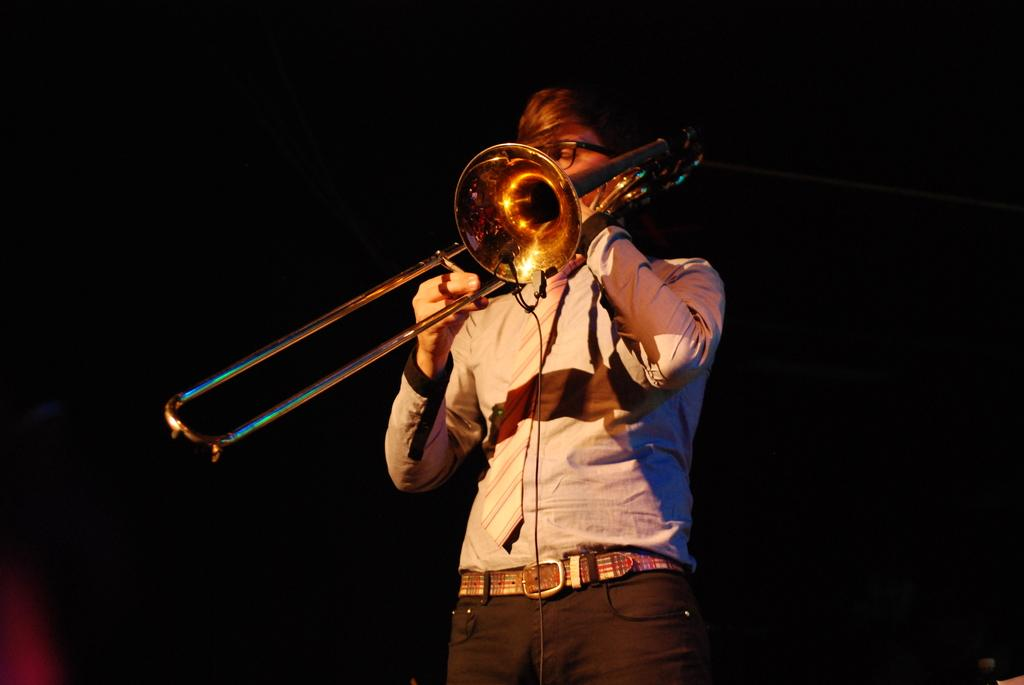What is the main subject of the image? There is a person in the image. What is the person doing in the image? The person is holding a musical instrument. Can you describe the background of the image? The background of the image is dark. What verse is the person reciting in the image? There is no verse being recited in the image; the person is holding a musical instrument. What type of test is the person taking in the image? There is no test being taken in the image; the person is holding a musical instrument. 